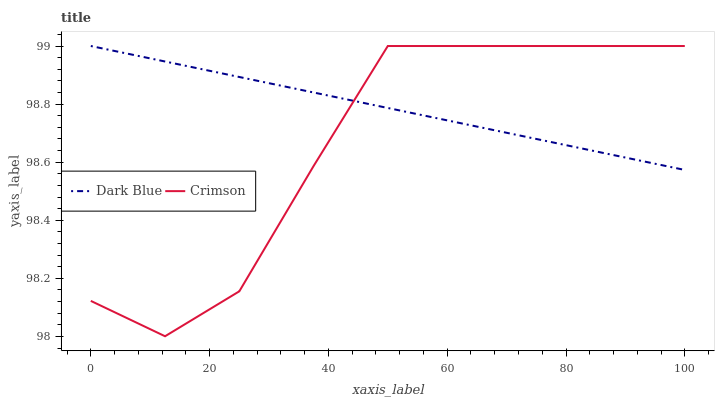Does Crimson have the minimum area under the curve?
Answer yes or no. Yes. Does Dark Blue have the maximum area under the curve?
Answer yes or no. Yes. Does Dark Blue have the minimum area under the curve?
Answer yes or no. No. Is Dark Blue the smoothest?
Answer yes or no. Yes. Is Crimson the roughest?
Answer yes or no. Yes. Is Dark Blue the roughest?
Answer yes or no. No. Does Crimson have the lowest value?
Answer yes or no. Yes. Does Dark Blue have the lowest value?
Answer yes or no. No. Does Dark Blue have the highest value?
Answer yes or no. Yes. Does Dark Blue intersect Crimson?
Answer yes or no. Yes. Is Dark Blue less than Crimson?
Answer yes or no. No. Is Dark Blue greater than Crimson?
Answer yes or no. No. 